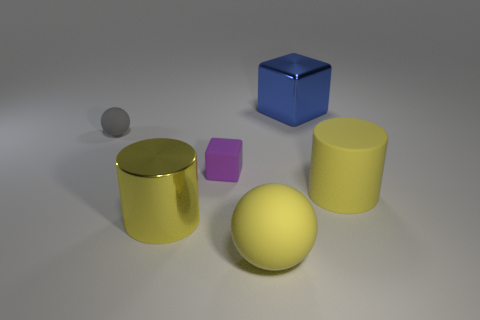Do the large yellow cylinder that is right of the big block and the blue thing have the same material?
Your answer should be compact. No. What number of things are the same material as the big blue cube?
Keep it short and to the point. 1. What is the material of the small purple block?
Provide a succinct answer. Rubber. The large metallic thing that is right of the purple thing in front of the gray rubber thing is what shape?
Offer a terse response. Cube. There is a tiny object that is on the right side of the small sphere; what is its shape?
Make the answer very short. Cube. How many big matte objects have the same color as the big metallic cylinder?
Keep it short and to the point. 2. The rubber cube is what color?
Your answer should be very brief. Purple. What number of yellow objects are left of the yellow matte object behind the big matte sphere?
Keep it short and to the point. 2. Is the size of the yellow rubber sphere the same as the yellow metallic thing on the right side of the tiny gray ball?
Make the answer very short. Yes. Do the blue shiny thing and the purple matte object have the same size?
Give a very brief answer. No. 